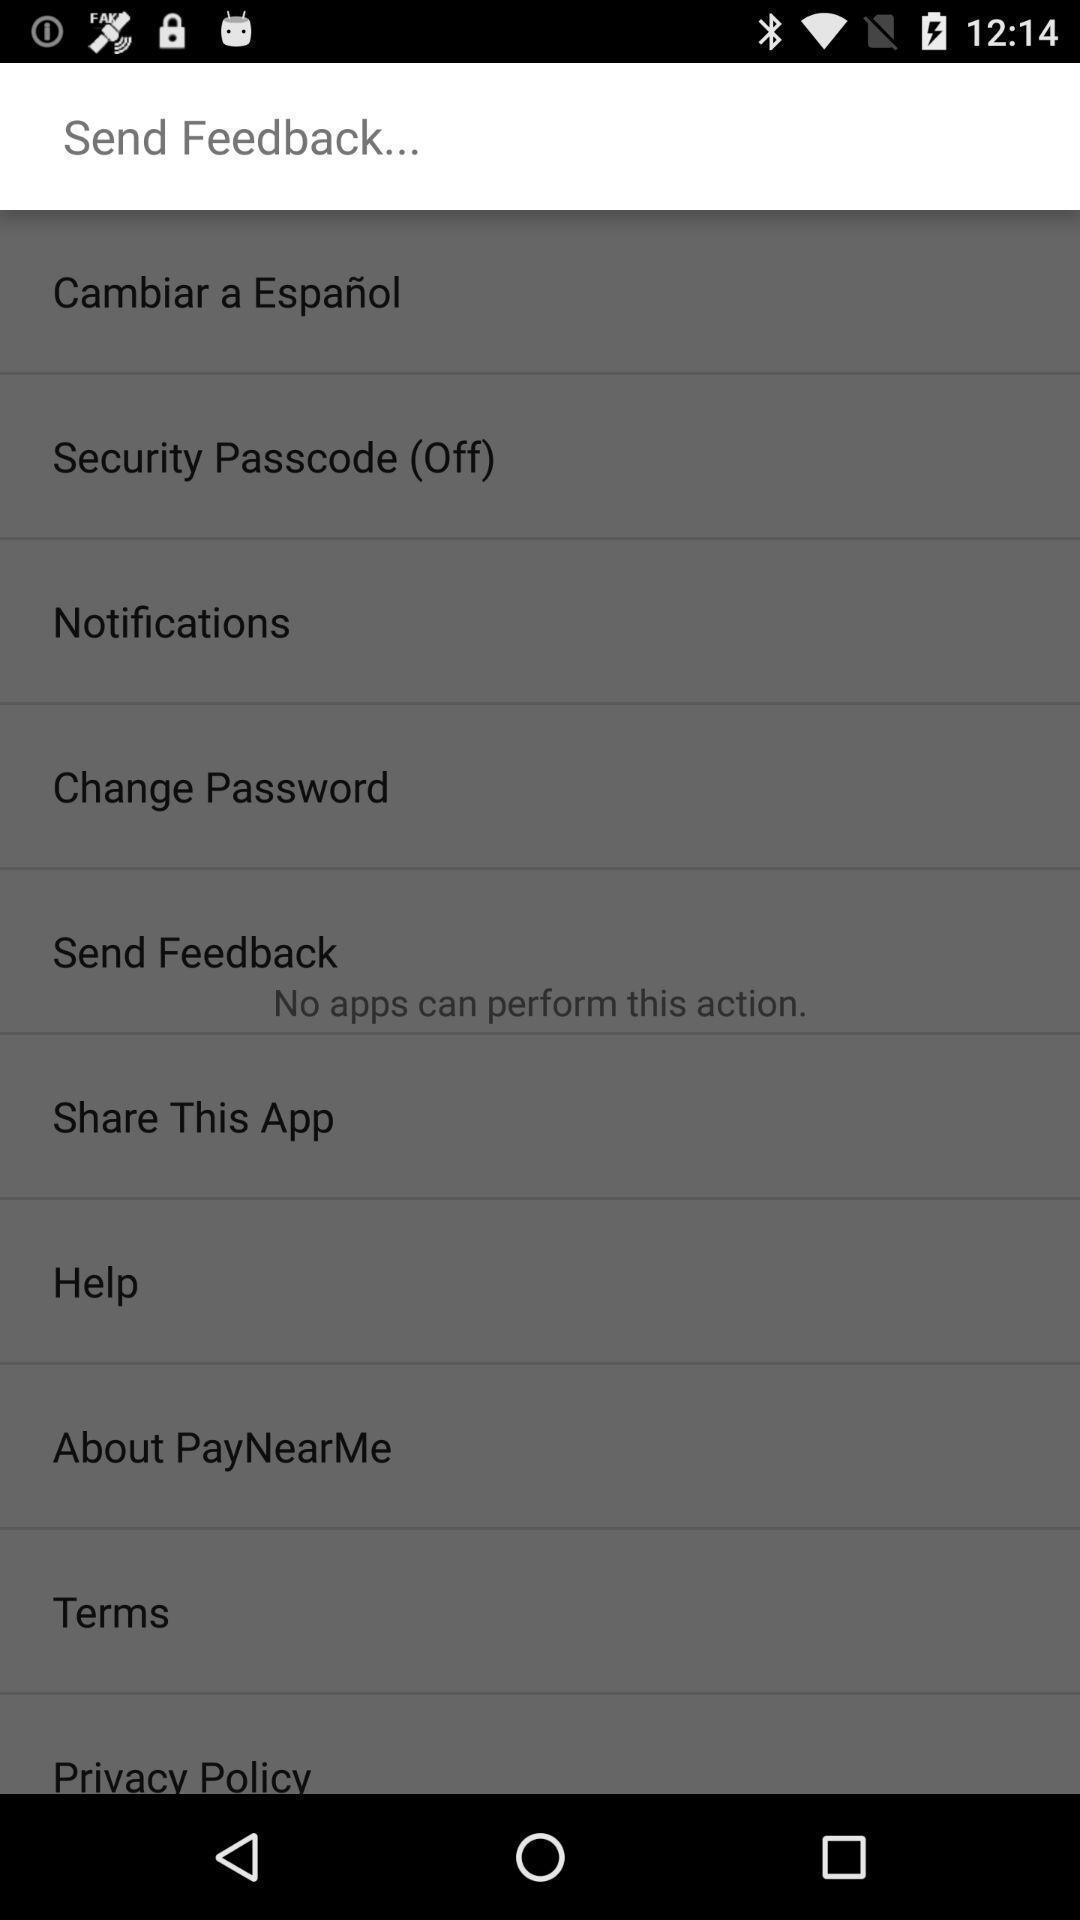Give me a summary of this screen capture. Send feedback in the page. 